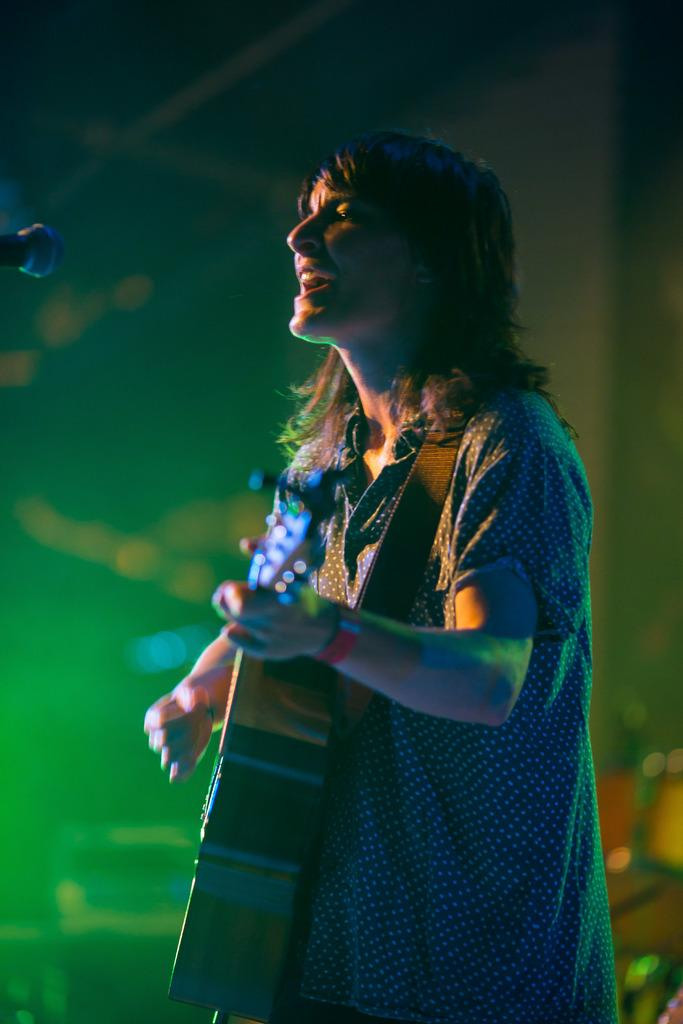Who is the main subject in the image? There is a lady in the center of the image. What is the lady holding in the image? The lady is holding a guitar. What can be seen on the left side of the image? There is a microphone on the left side of the image. What type of wall can be seen behind the lady in the image? There is no wall visible behind the lady in the image. How does the lady rest her guitar during the performance? The image does not show the lady resting her guitar, so it cannot be determined from the image. 